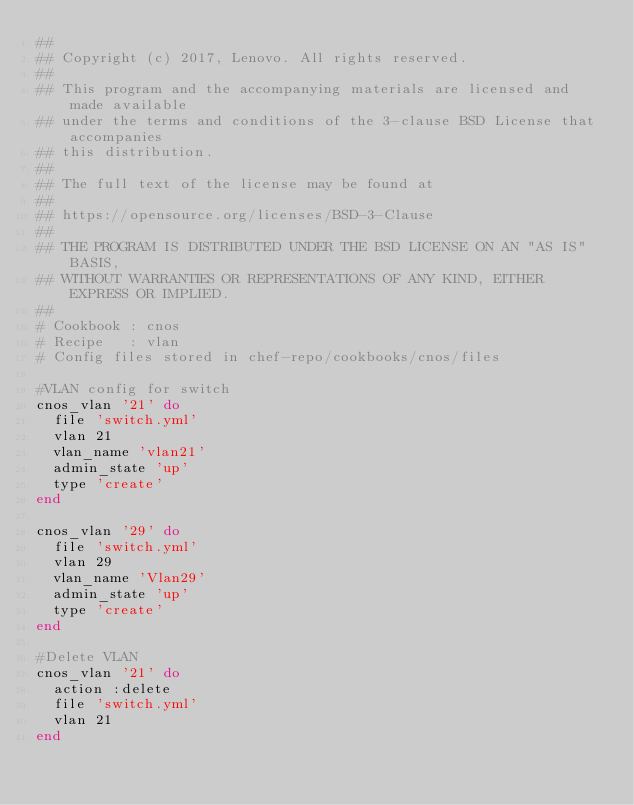Convert code to text. <code><loc_0><loc_0><loc_500><loc_500><_Ruby_>##
## Copyright (c) 2017, Lenovo. All rights reserved.
##
## This program and the accompanying materials are licensed and made available
## under the terms and conditions of the 3-clause BSD License that accompanies
## this distribution.
##
## The full text of the license may be found at
##
## https://opensource.org/licenses/BSD-3-Clause
##
## THE PROGRAM IS DISTRIBUTED UNDER THE BSD LICENSE ON AN "AS IS" BASIS,
## WITHOUT WARRANTIES OR REPRESENTATIONS OF ANY KIND, EITHER EXPRESS OR IMPLIED.
##
# Cookbook : cnos
# Recipe   : vlan
# Config files stored in chef-repo/cookbooks/cnos/files

#VLAN config for switch
cnos_vlan '21' do
	file 'switch.yml'
	vlan 21
	vlan_name 'vlan21'
	admin_state 'up'
	type 'create'
end

cnos_vlan '29' do
	file 'switch.yml'
	vlan 29
	vlan_name 'Vlan29'
	admin_state 'up'
	type 'create'
end

#Delete VLAN
cnos_vlan '21' do
	action :delete
	file 'switch.yml'
	vlan 21
end
</code> 